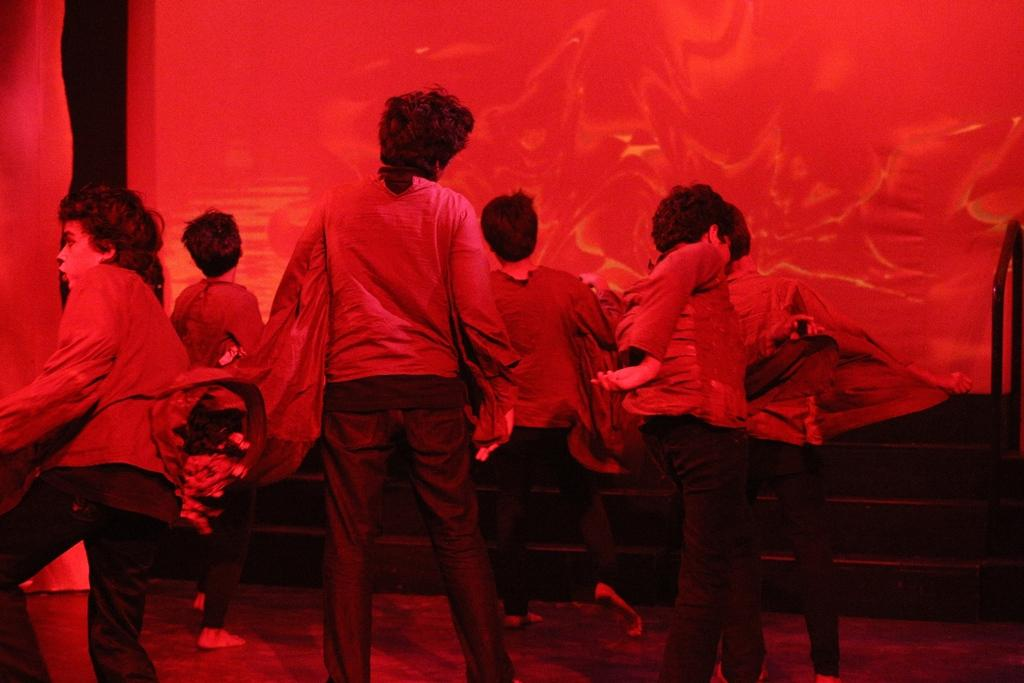What is happening on the stage in the image? There is a group of people standing on the stage. What can be seen in the background of the image? There are stairs and curtains visible in the background. What type of metal is being used to perform arithmetic calculations in the image? There is no metal or arithmetic calculations present in the image. 